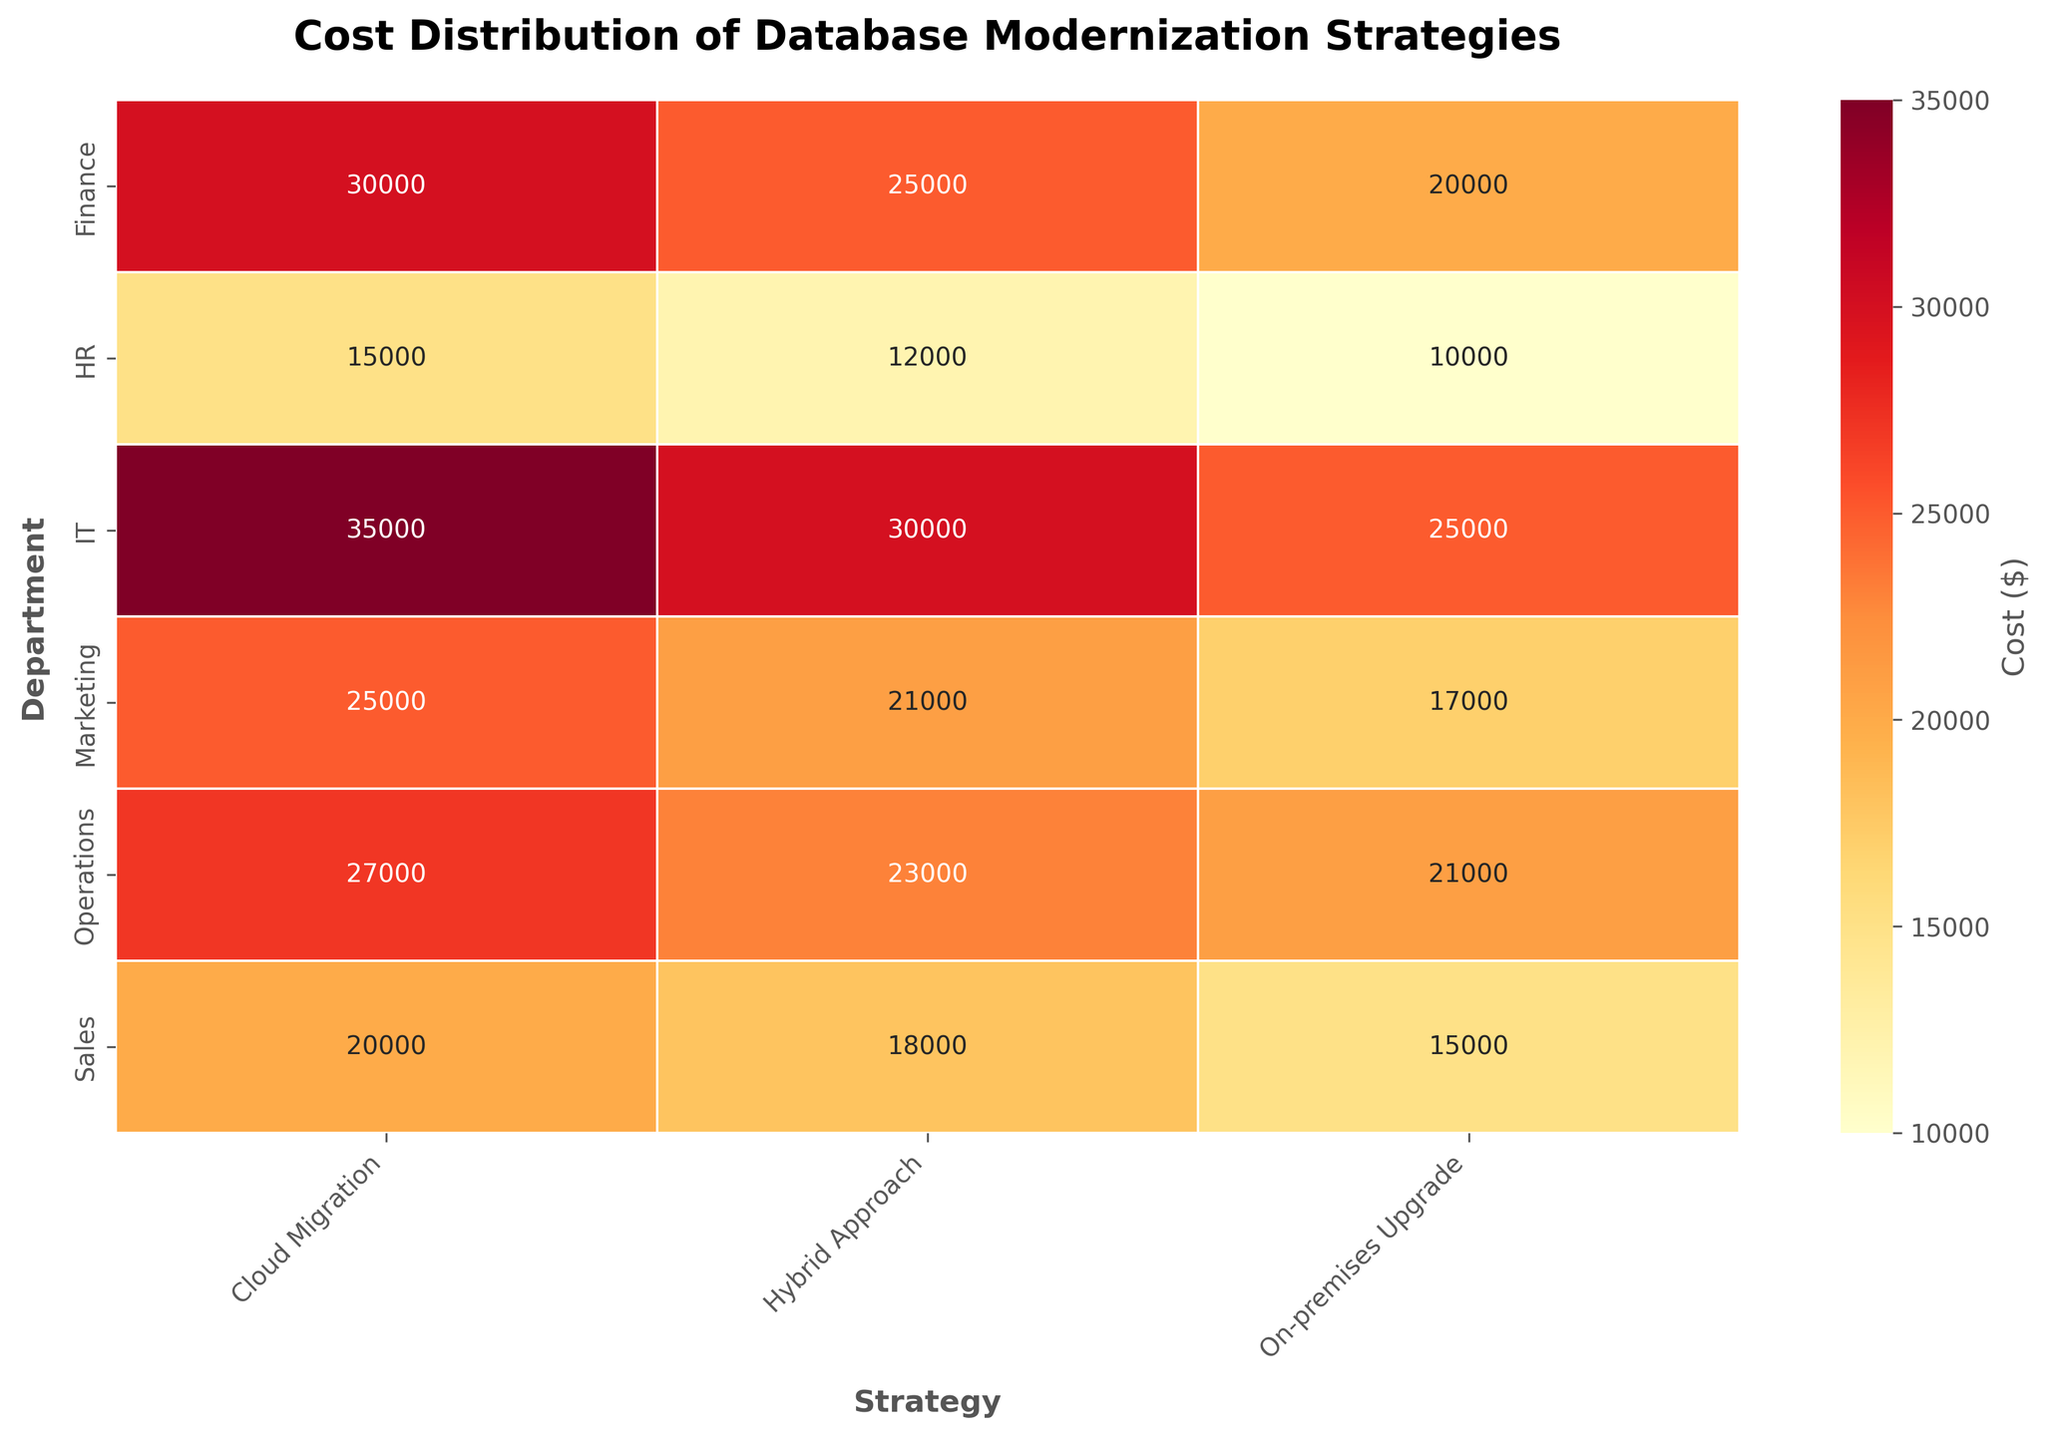What is the highest cost listed in the heatmap? The highest cost can be identified by surveying the heatmap data for the maximum value. Here, the highest cost is found under the IT department for the Cloud Migration strategy.
Answer: 35000 Which department has the lowest cost for database modernization and what strategy is it? By scanning the heatmap for the minimum value, the lowest cost of 10000 is found in the HR department under the On-premises Upgrade strategy.
Answer: HR, On-premises Upgrade How much more expensive is the Cloud Migration strategy compared to On-premises Upgrade for the Finance department? The cost for Cloud Migration in Finance is 30000, and the cost for On-premises Upgrade is 20000. The difference is calculated as 30000 - 20000 = 10000.
Answer: 10000 Which strategy generally costs the most across all departments? Summing the costs for each strategy across all departments yields: Cloud Migration (20000 + 25000 + 30000 + 15000 + 35000 + 27000), On-premises Upgrade (15000 + 17000 + 20000 + 10000 + 25000 + 21000), Hybrid Approach (18000 + 21000 + 25000 + 12000 + 30000 + 23000). The highest total cost belongs to Cloud Migration.
Answer: Cloud Migration Are there any departments where the Hybrid Approach is costlier than both Cloud Migration and On-premises Upgrade? By analyzing each department, we find the Hybrid Approach is costlier in the Sales department (18000 > 15000), Marketing department (21000 > 17000), and Operations department (23000 > 21000). In each of these cases, these costs are higher than both alternative strategies.
Answer: Yes Which department experiences the smallest cost difference between Cloud Migration and On-premises Upgrade? Calculating the differences between these two strategies for each department: Sales (5000), Marketing (8000), Finance (10000), HR (5000), IT (10000), Operations (6000). Both Sales and HR have the smallest cost differences of 5000.
Answer: Sales and HR What's the average cost of the Hybrid Approach strategy across all departments? Summing the Hybrid Approach costs for all departments (18000 + 21000 + 25000 + 12000 + 30000 + 23000) equals 129000. Dividing this by the number of departments (6) results in an average of 21500.
Answer: 21500 Which department has the most consistent costs across all three strategies? The department with the smallest range between the highest and lowest costs is found by computing the range per each department: Sales (20000 - 15000 = 5000), Marketing (25000 - 17000 = 8000), Finance (30000 - 20000 = 10000), HR (15000 - 10000 = 5000), IT (35000 - 25000 = 10000), Operations (27000 - 21000 = 6000). Both Sales and HR have the smallest cost range of 5000, indicating the most consistency.
Answer: Sales and HR 